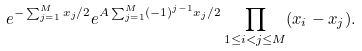<formula> <loc_0><loc_0><loc_500><loc_500>e ^ { - \sum _ { j = 1 } ^ { M } x _ { j } / 2 } e ^ { A \sum _ { j = 1 } ^ { M } ( - 1 ) ^ { j - 1 } x _ { j } / 2 } \prod _ { 1 \leq i < j \leq M } ( x _ { i } - x _ { j } ) .</formula> 